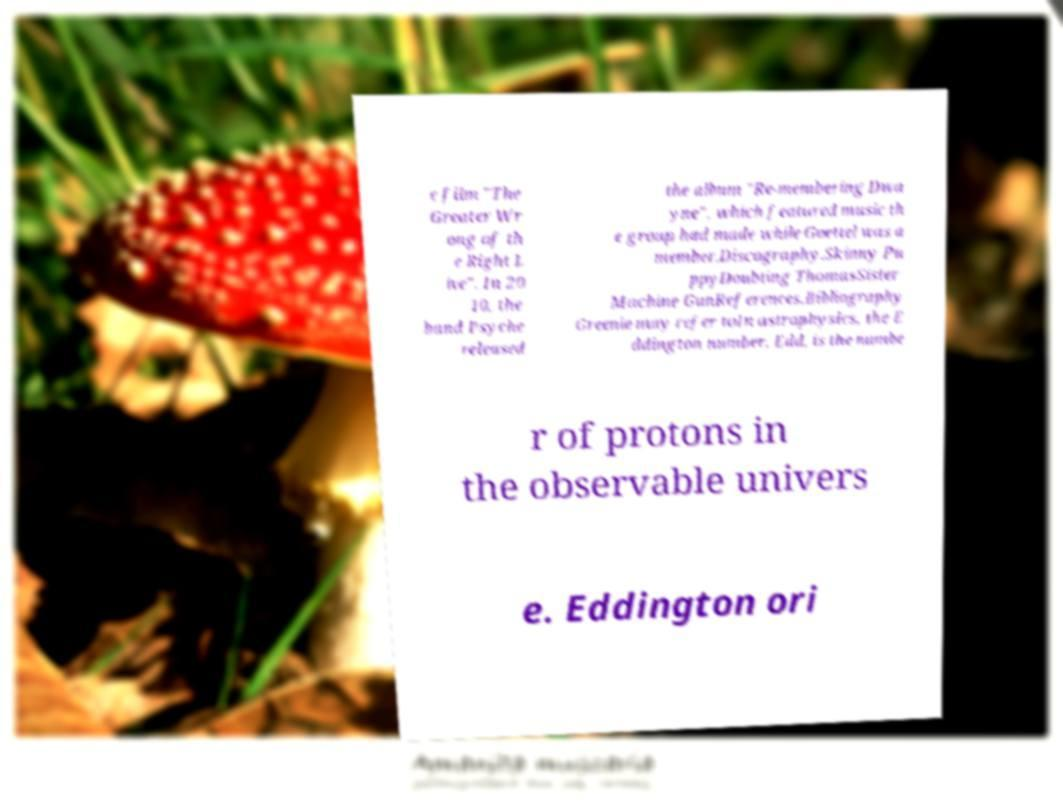For documentation purposes, I need the text within this image transcribed. Could you provide that? e film "The Greater Wr ong of th e Right L ive". In 20 10, the band Psyche released the album "Re-membering Dwa yne", which featured music th e group had made while Goettel was a member.Discography.Skinny Pu ppyDoubting ThomasSister Machine GunReferences.Bibliography Greenie may refer toIn astrophysics, the E ddington number, Edd, is the numbe r of protons in the observable univers e. Eddington ori 